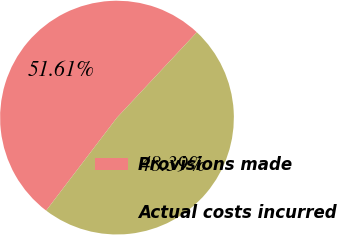Convert chart to OTSL. <chart><loc_0><loc_0><loc_500><loc_500><pie_chart><fcel>Provisions made<fcel>Actual costs incurred<nl><fcel>51.61%<fcel>48.39%<nl></chart> 